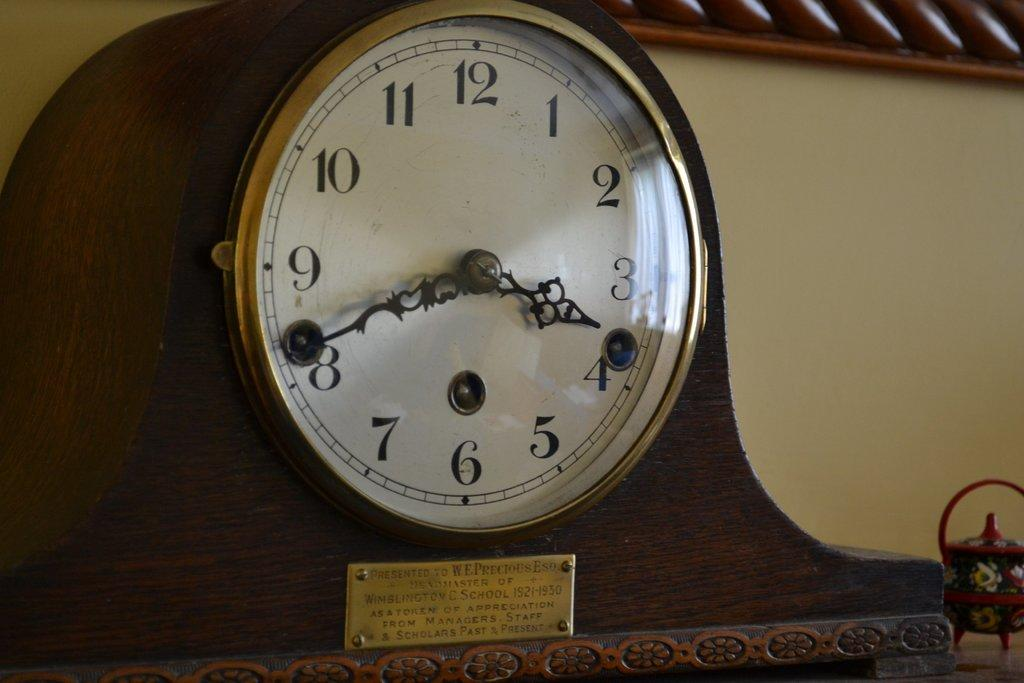<image>
Write a terse but informative summary of the picture. Clock which has the hands on the number 4 and 8. 